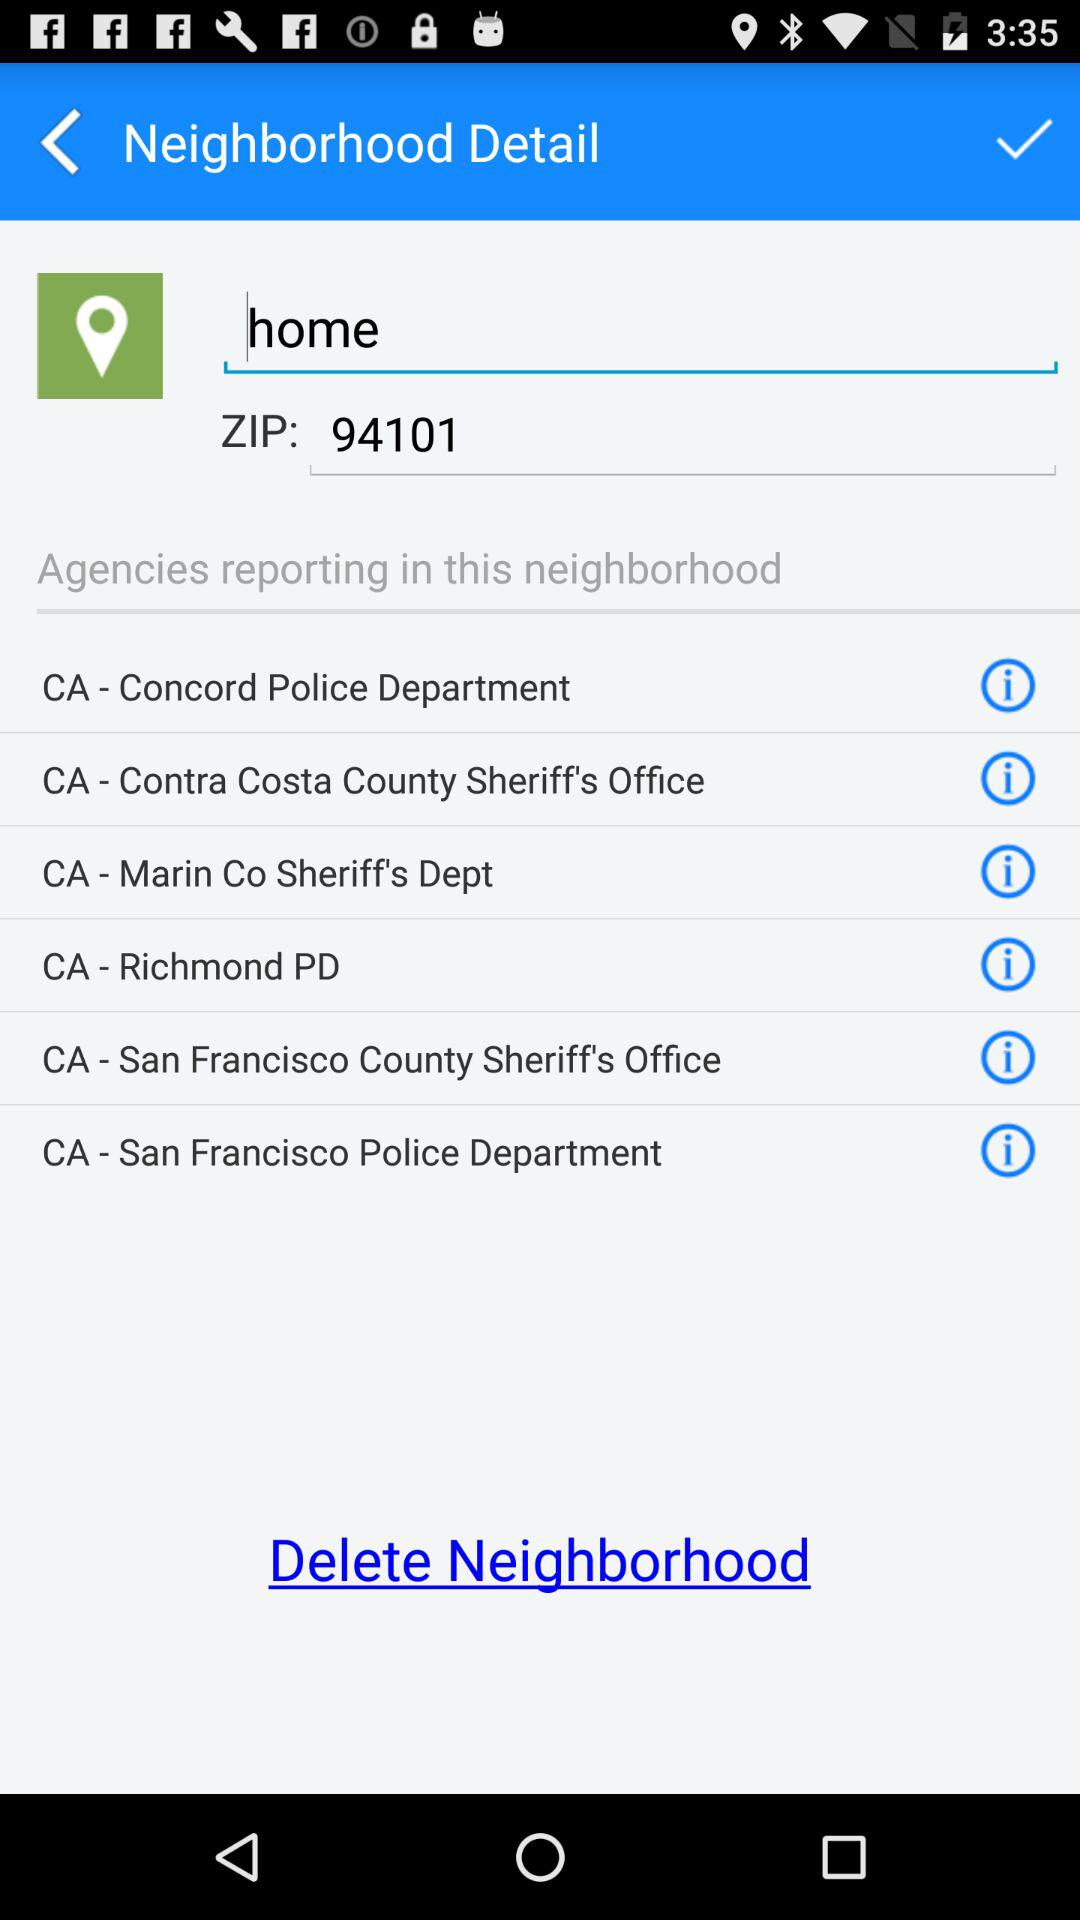What is the zip code? The zip code is 94101. 